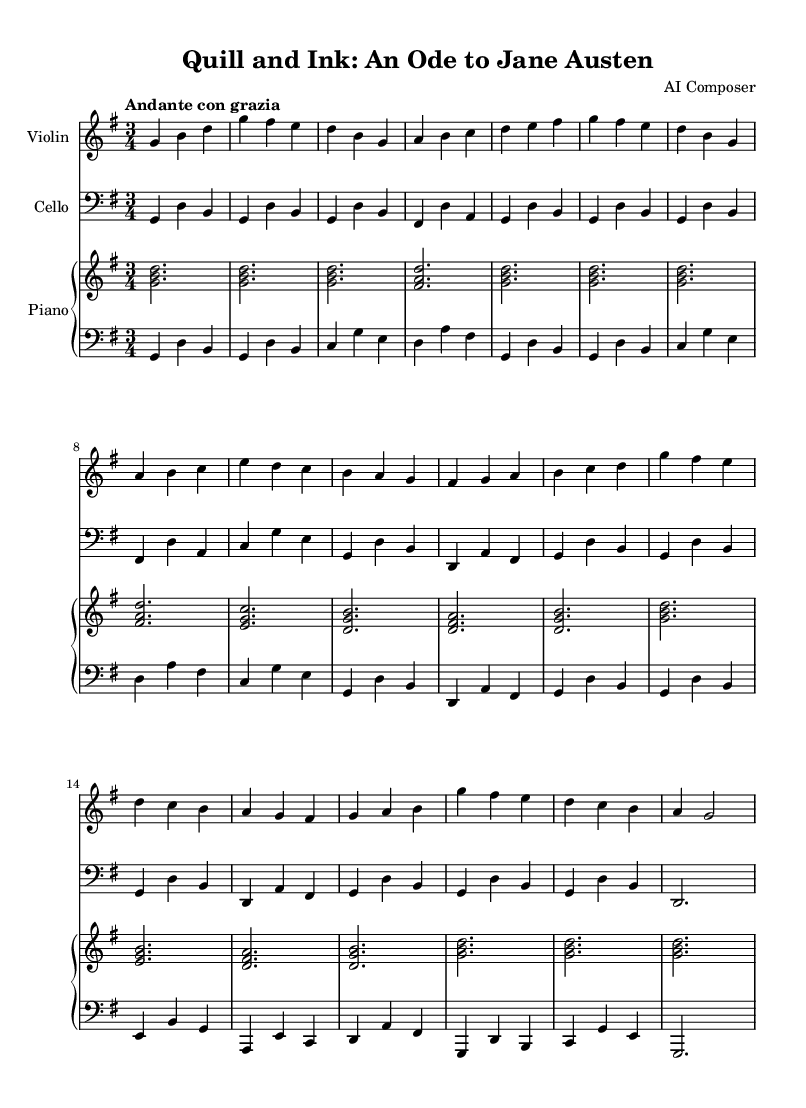What is the key signature of this music? The key signature is G major, which has one sharp (F sharp). This can be determined from the key signature notation at the beginning of the score.
Answer: G major What is the time signature of this music? The time signature is 3/4, indicated at the start of the score. This means there are three beats in each measure and the quarter note gets one beat.
Answer: 3/4 What is the tempo marking for this piece? The tempo marking is "Andante con grazia," which suggests a moderately slow tempo with gracefulness. This marking appears at the beginning of the score.
Answer: Andante con grazia How many themes are presented in this composition? There are two main themes, Theme A and Theme B, as indicated in the musical structure where Theme A appears multiple times and Theme B is also specified.
Answer: 2 themes What instrument plays the highest notes in this score? The violin plays the highest notes, as it is positioned above the cello and piano in the score. The range of the violin parts typically goes higher than the cello and piano parts.
Answer: Violin Which theme has a variation in this composition? Theme A has a variation, identified in the score as "Theme A variation," where it follows the regular presentation of Theme A. This indicates a development of the original theme.
Answer: Theme A variation 